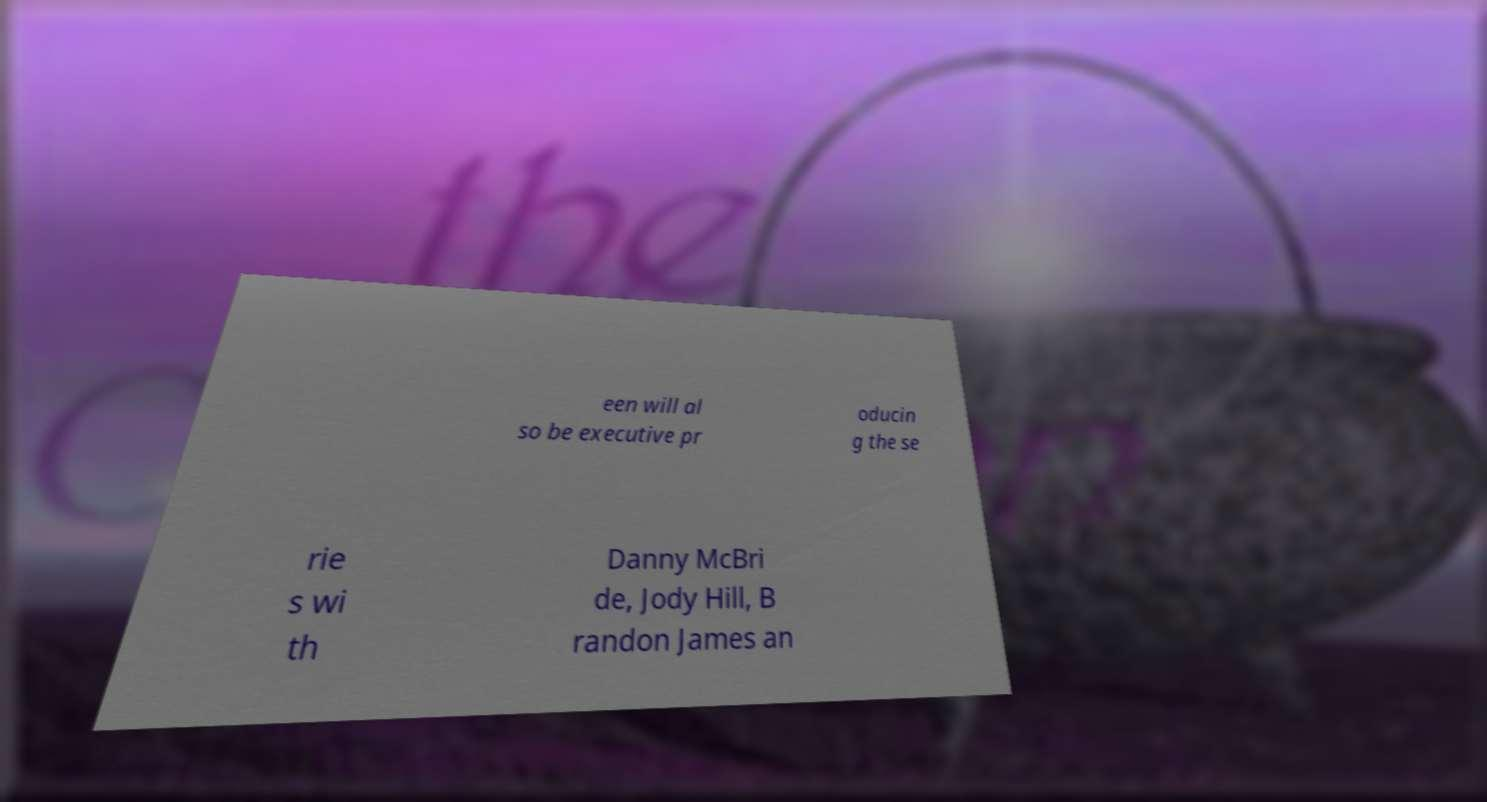There's text embedded in this image that I need extracted. Can you transcribe it verbatim? een will al so be executive pr oducin g the se rie s wi th Danny McBri de, Jody Hill, B randon James an 